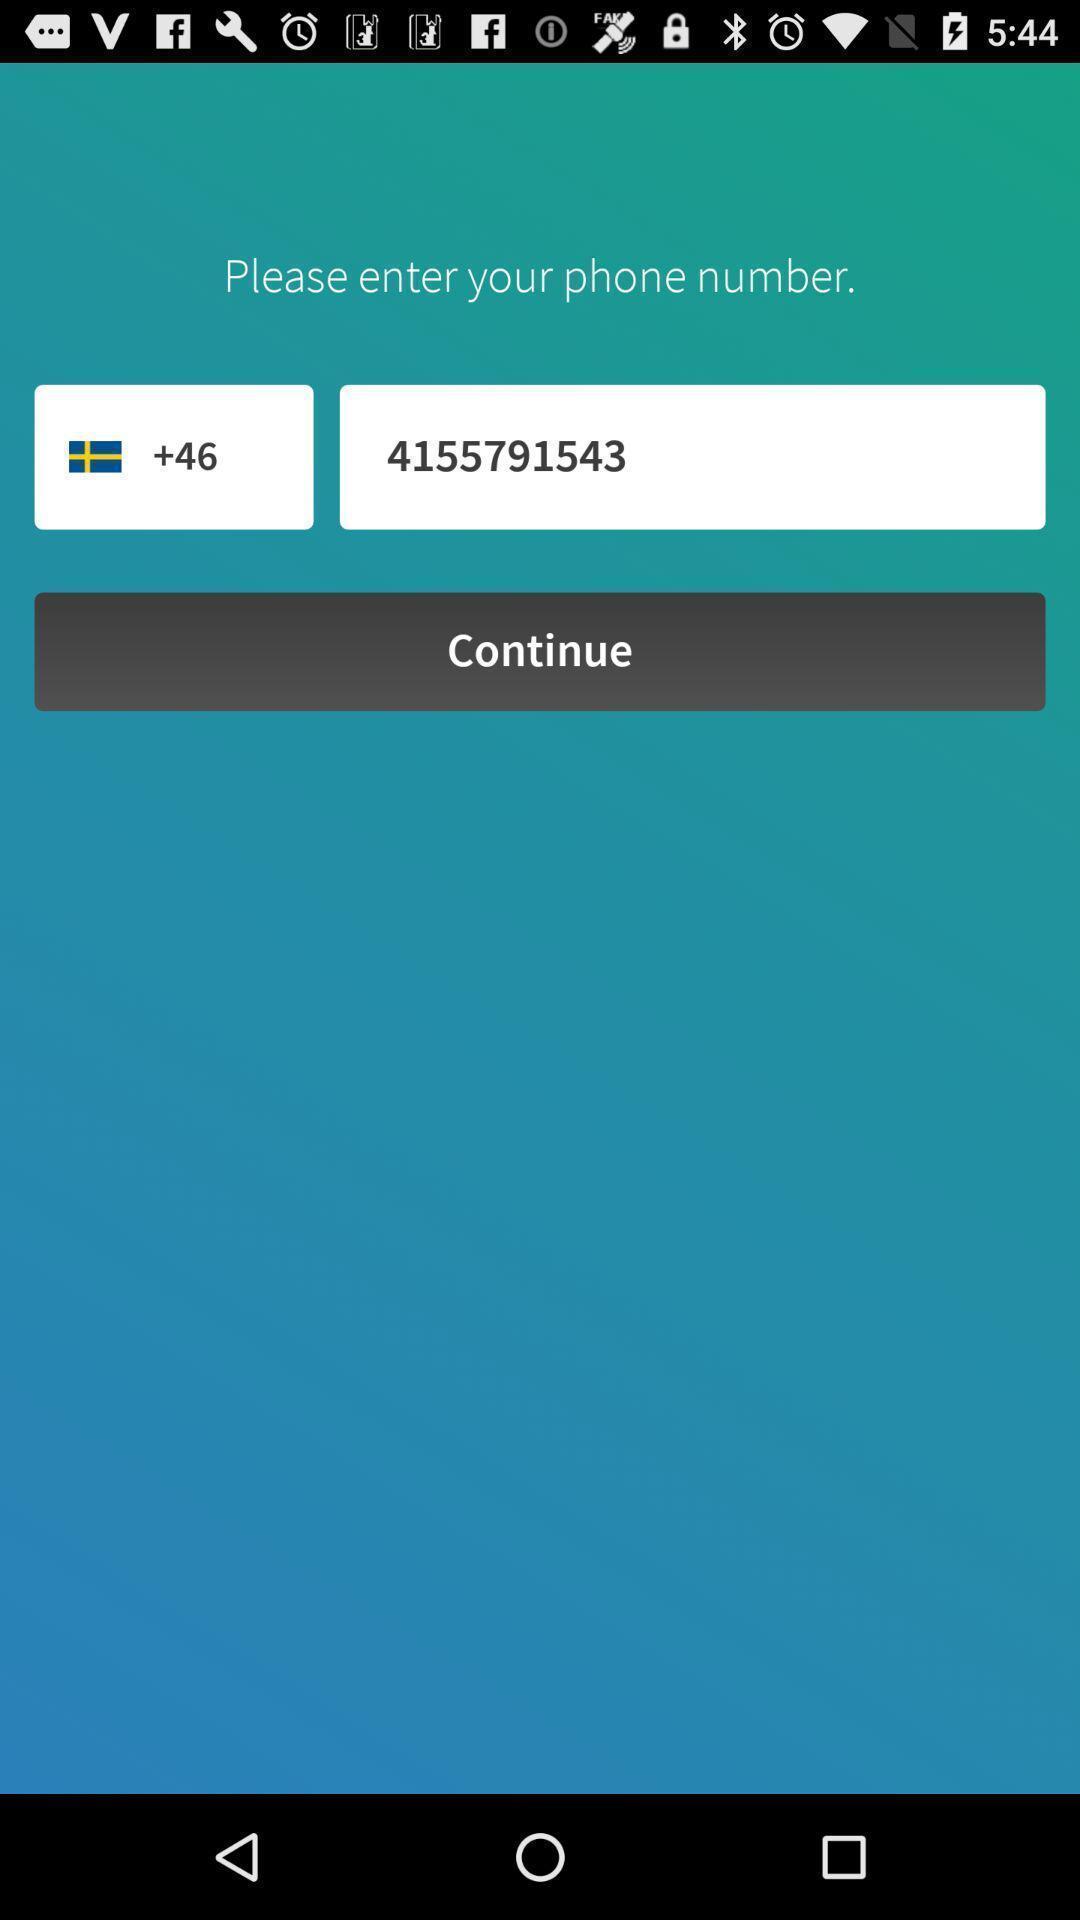What details can you identify in this image? Screen displaying user contact information and country code. 